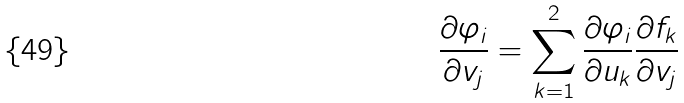<formula> <loc_0><loc_0><loc_500><loc_500>\frac { \partial \varphi _ { i } } { \partial v _ { j } } = \sum _ { k = 1 } ^ { 2 } \frac { \partial \varphi _ { i } } { \partial u _ { k } } \frac { \partial f _ { k } } { \partial v _ { j } }</formula> 